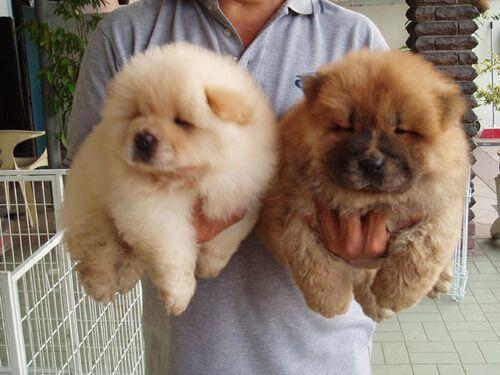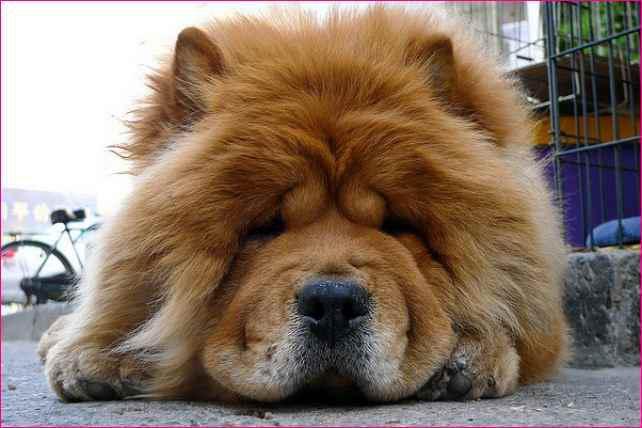The first image is the image on the left, the second image is the image on the right. Examine the images to the left and right. Is the description "There are more living dogs in the image on the left." accurate? Answer yes or no. Yes. The first image is the image on the left, the second image is the image on the right. For the images displayed, is the sentence "The left image contains at least two chow dogs." factually correct? Answer yes or no. Yes. 